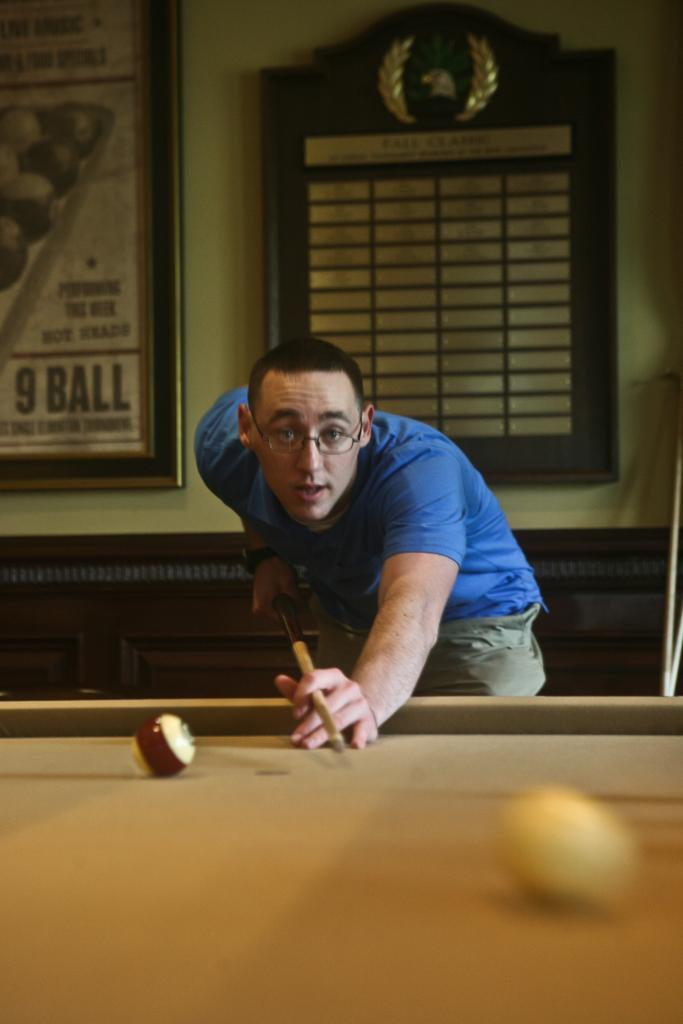Who is present in the image? There is a man in the image. What is the man doing in the image? The man is hitting a ball in the image. What type of table is in the image? There is a billiards table in the image. What type of distribution system is present in the image? There is no distribution system present in the image; it features a man hitting a ball on a billiards table. Can you see any army personnel in the image? There is no army personnel present in the image. 